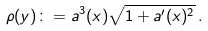Convert formula to latex. <formula><loc_0><loc_0><loc_500><loc_500>\rho ( y ) \colon = a ^ { 3 } ( x ) \sqrt { 1 + { a ^ { \prime } } ( x ) ^ { 2 } } \, .</formula> 